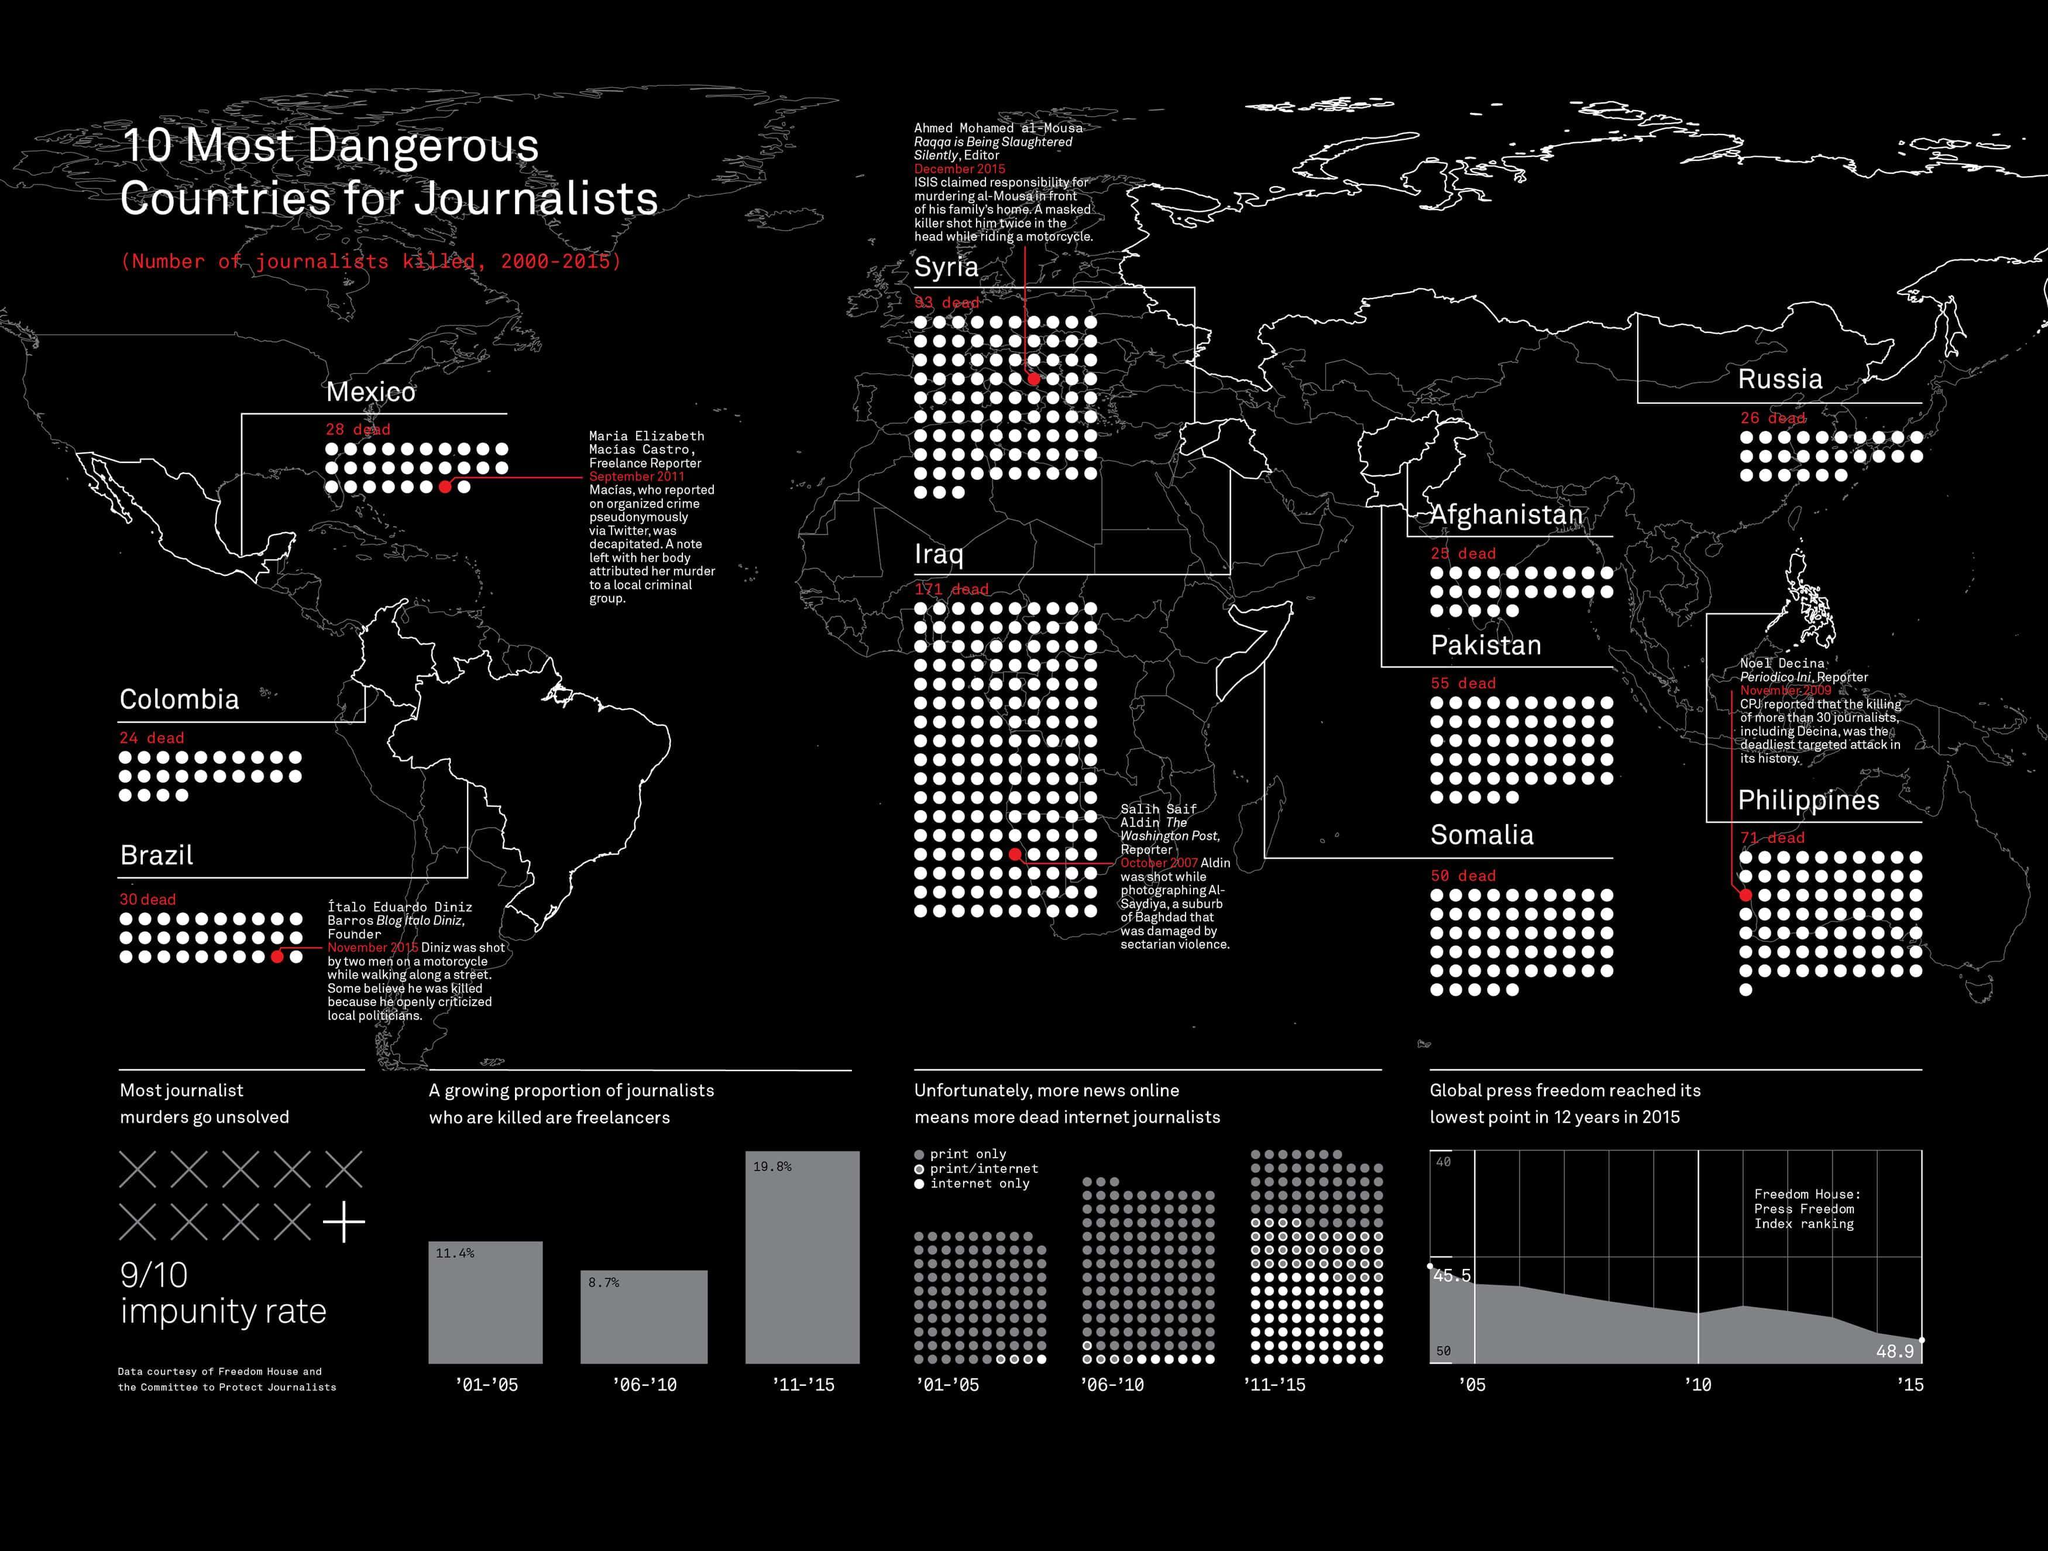Which country has reported the second-highest number of journalists death among the ten most dangerous countries for journalists during 2000-2015?
Answer the question with a short phrase. Syria How many journalists were killed in Afghanistan during 2000-2015? 25 How many journalists were killed in Pakistan during 2000-2015? 55 Which country has reported the highest number of journalists death among the ten most dangerous countries for journalists during 2000-2015? Iraq 